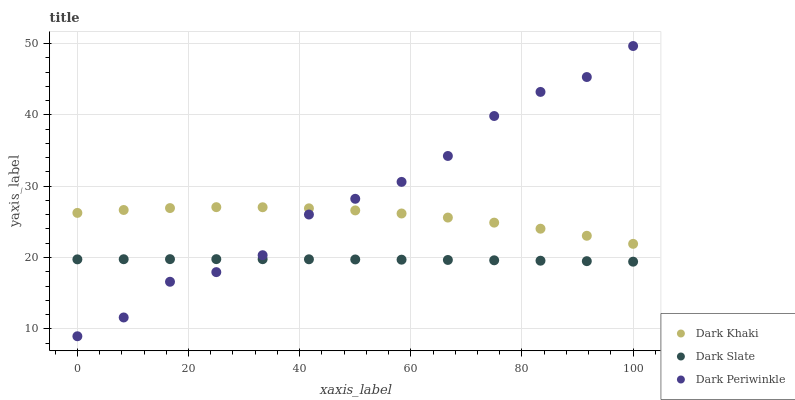Does Dark Slate have the minimum area under the curve?
Answer yes or no. Yes. Does Dark Periwinkle have the maximum area under the curve?
Answer yes or no. Yes. Does Dark Periwinkle have the minimum area under the curve?
Answer yes or no. No. Does Dark Slate have the maximum area under the curve?
Answer yes or no. No. Is Dark Slate the smoothest?
Answer yes or no. Yes. Is Dark Periwinkle the roughest?
Answer yes or no. Yes. Is Dark Periwinkle the smoothest?
Answer yes or no. No. Is Dark Slate the roughest?
Answer yes or no. No. Does Dark Periwinkle have the lowest value?
Answer yes or no. Yes. Does Dark Slate have the lowest value?
Answer yes or no. No. Does Dark Periwinkle have the highest value?
Answer yes or no. Yes. Does Dark Slate have the highest value?
Answer yes or no. No. Is Dark Slate less than Dark Khaki?
Answer yes or no. Yes. Is Dark Khaki greater than Dark Slate?
Answer yes or no. Yes. Does Dark Khaki intersect Dark Periwinkle?
Answer yes or no. Yes. Is Dark Khaki less than Dark Periwinkle?
Answer yes or no. No. Is Dark Khaki greater than Dark Periwinkle?
Answer yes or no. No. Does Dark Slate intersect Dark Khaki?
Answer yes or no. No. 